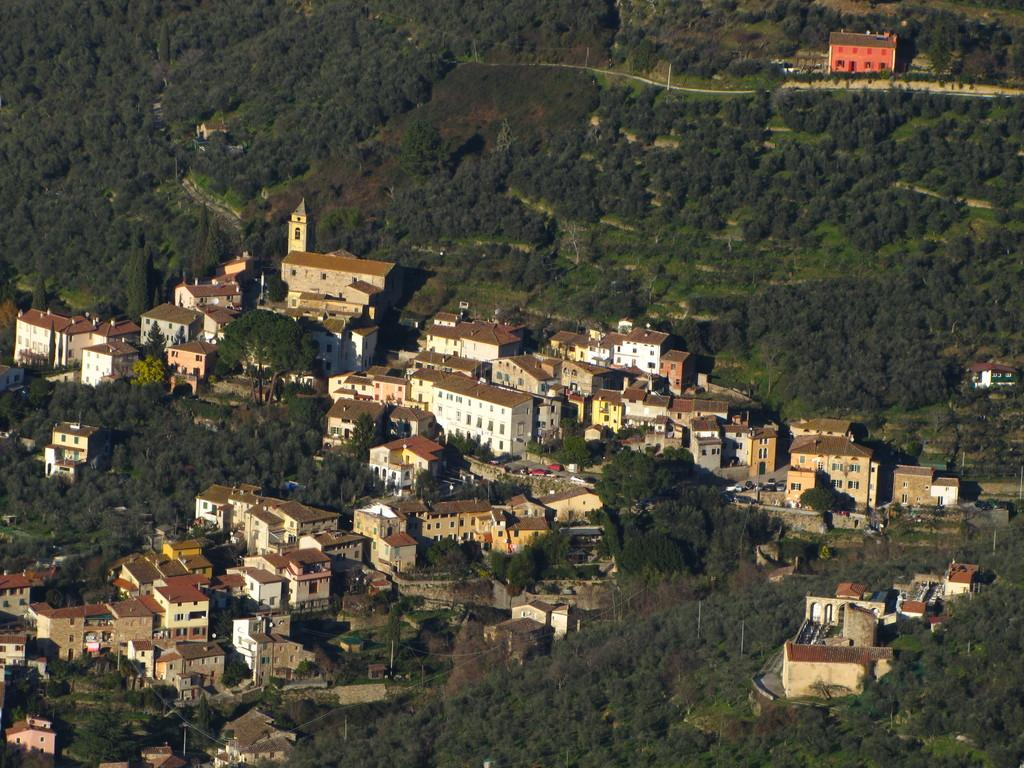What type of view is shown in the image? The image is an aerial view. What structures can be seen from this perspective? There are buildings visible in the image. What natural elements can be seen in the image? There are trees visible in the image. What type of game is being played on the board in the image? There is no board or game present in the image; it is an aerial view of buildings and trees. 